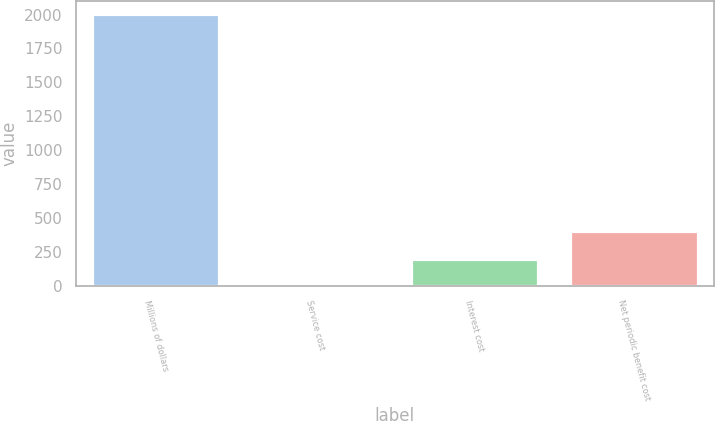<chart> <loc_0><loc_0><loc_500><loc_500><bar_chart><fcel>Millions of dollars<fcel>Service cost<fcel>Interest cost<fcel>Net periodic benefit cost<nl><fcel>2003<fcel>1<fcel>201.2<fcel>401.4<nl></chart> 